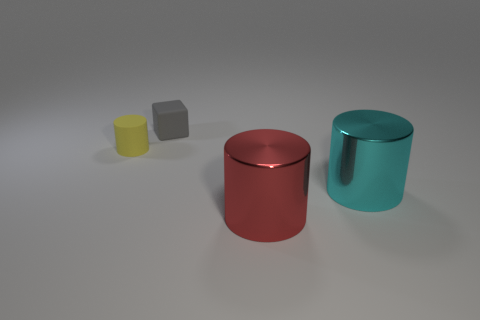Subtract all large red cylinders. How many cylinders are left? 2 Subtract all cyan cylinders. How many cylinders are left? 2 Subtract 1 cylinders. How many cylinders are left? 2 Add 1 tiny yellow matte objects. How many objects exist? 5 Subtract all cylinders. How many objects are left? 1 Subtract all brown cylinders. Subtract all yellow cubes. How many cylinders are left? 3 Add 2 cyan metallic blocks. How many cyan metallic blocks exist? 2 Subtract 0 green cubes. How many objects are left? 4 Subtract all small yellow rubber objects. Subtract all yellow matte things. How many objects are left? 2 Add 1 cubes. How many cubes are left? 2 